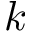<formula> <loc_0><loc_0><loc_500><loc_500>k</formula> 